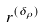Convert formula to latex. <formula><loc_0><loc_0><loc_500><loc_500>r ^ { ( \delta _ { \rho } ) }</formula> 